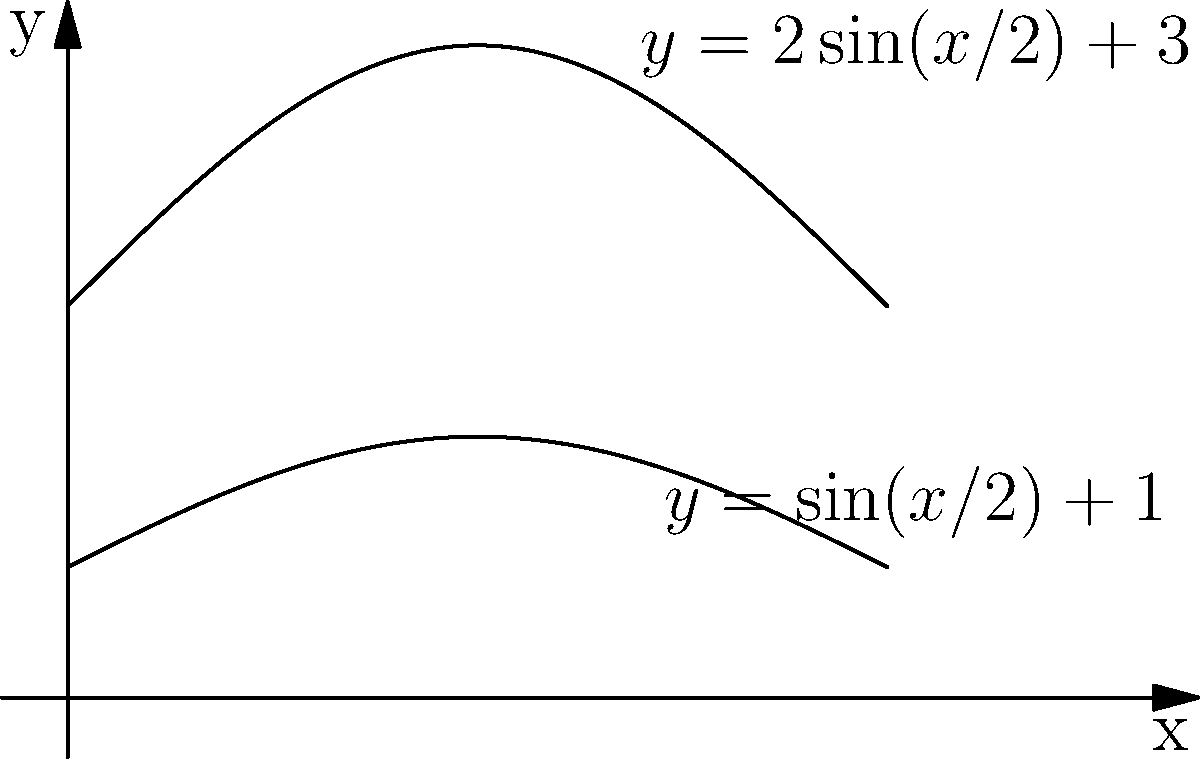Jason & the Scorchers are known for their unique guitar designs. Inspired by their style, a luthier has created a guitar body with a cross-section described by the region bounded by the curves $y=2\sin(x/2)+3$ and $y=\sin(x/2)+1$ from $x=0$ to $x=2\pi$. If this cross-section is rotated around the x-axis to form the guitar body, what is the volume of the resulting solid? To solve this problem, we'll use the washer method for volumes of revolution:

1) The volume is given by the integral: 
   $$V = \pi \int_0^{2\pi} [(2\sin(x/2)+3)^2 - (\sin(x/2)+1)^2] dx$$

2) Expand the integrand:
   $$V = \pi \int_0^{2\pi} [4\sin^2(x/2)+12\sin(x/2)+9 - \sin^2(x/2)-2\sin(x/2)-1] dx$$

3) Simplify:
   $$V = \pi \int_0^{2\pi} [3\sin^2(x/2)+10\sin(x/2)+8] dx$$

4) Use the substitution $u=x/2$, $du=dx/2$:
   $$V = 2\pi \int_0^{\pi} [3\sin^2(u)+10\sin(u)+8] du$$

5) Integrate term by term:
   $$V = 2\pi [\frac{3}{2}(u-\sin(u)\cos(u))-10\cos(u)+8u]_0^{\pi}$$

6) Evaluate the definite integral:
   $$V = 2\pi [\frac{3}{2}(\pi-0)+10-10+8\pi]$$

7) Simplify:
   $$V = 2\pi [\frac{3\pi}{2}+8\pi] = 2\pi [\frac{19\pi}{2}] = 19\pi^2$$
Answer: $19\pi^2$ cubic units 